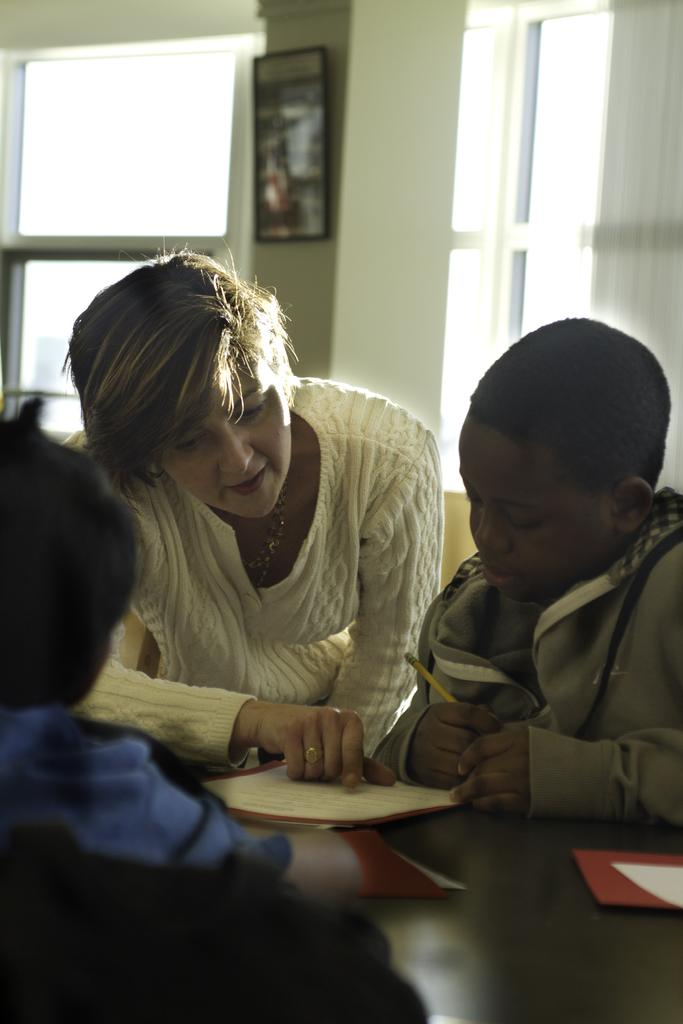How many people are in the image? There are two kids and a woman in the image, making a total of three people. What is the woman wearing in the image? The woman is wearing a sweatshirt in the image. Where are the kids and the woman located in the image? They are sitting in front of a table in the image. What items can be seen on the table? There are books on the table in the image. What architectural feature is visible in the background of the image? There are windows on the wall in the background of the image. Can you tell me how many rabbits are sitting on the table with the books? There are no rabbits present in the image; only the two kids, the woman, and the books are visible on the table. 